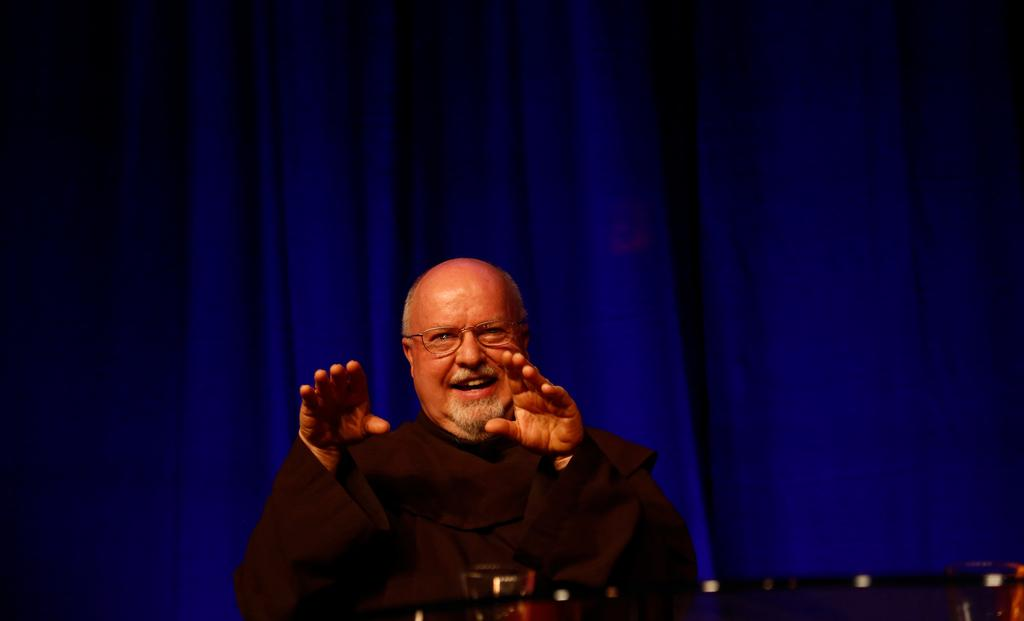What is the primary subject of the image? There is a person standing in the image. What is in front of the person? There is a table in front of the person. What can be seen in the background of the image? There is a curtain visible in the background of the image. How many boats are visible in the image? There are no boats present in the image. What type of hose is being used by the person in the image? There is no hose visible in the image. 